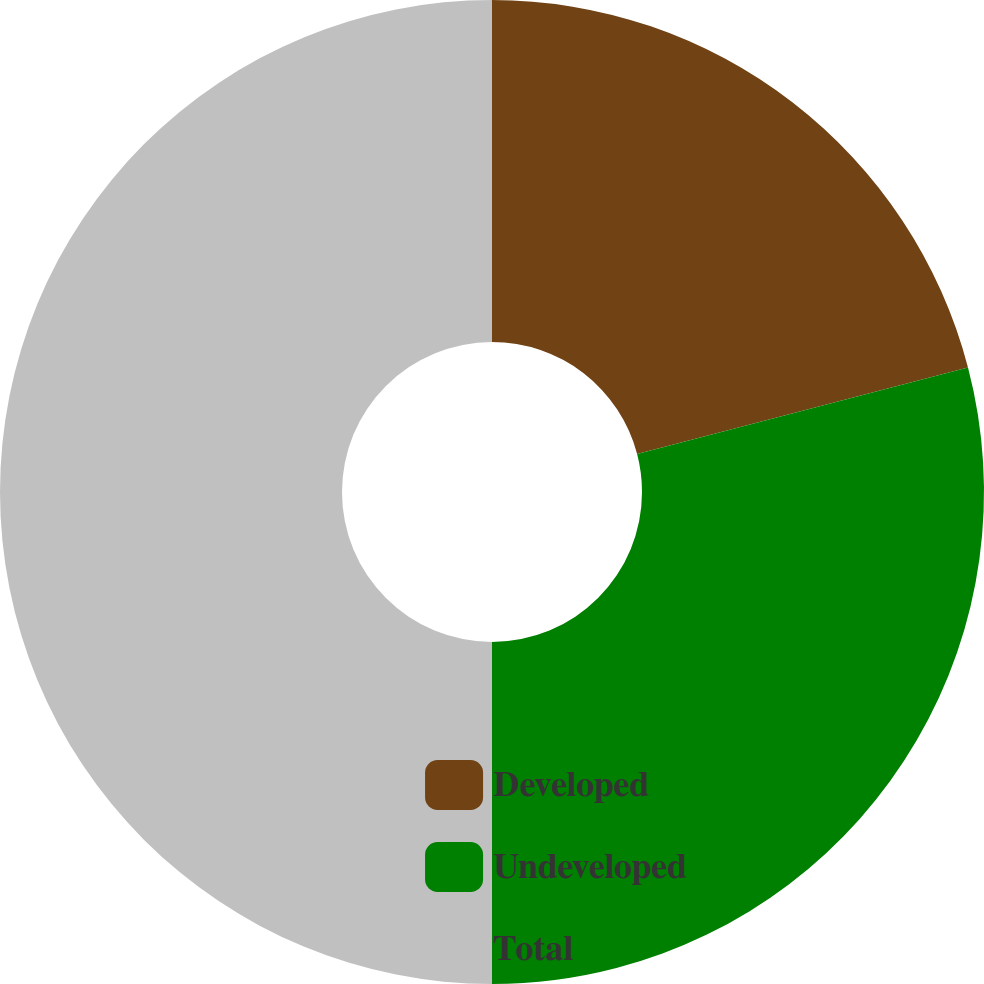Convert chart. <chart><loc_0><loc_0><loc_500><loc_500><pie_chart><fcel>Developed<fcel>Undeveloped<fcel>Total<nl><fcel>20.93%<fcel>29.07%<fcel>50.0%<nl></chart> 